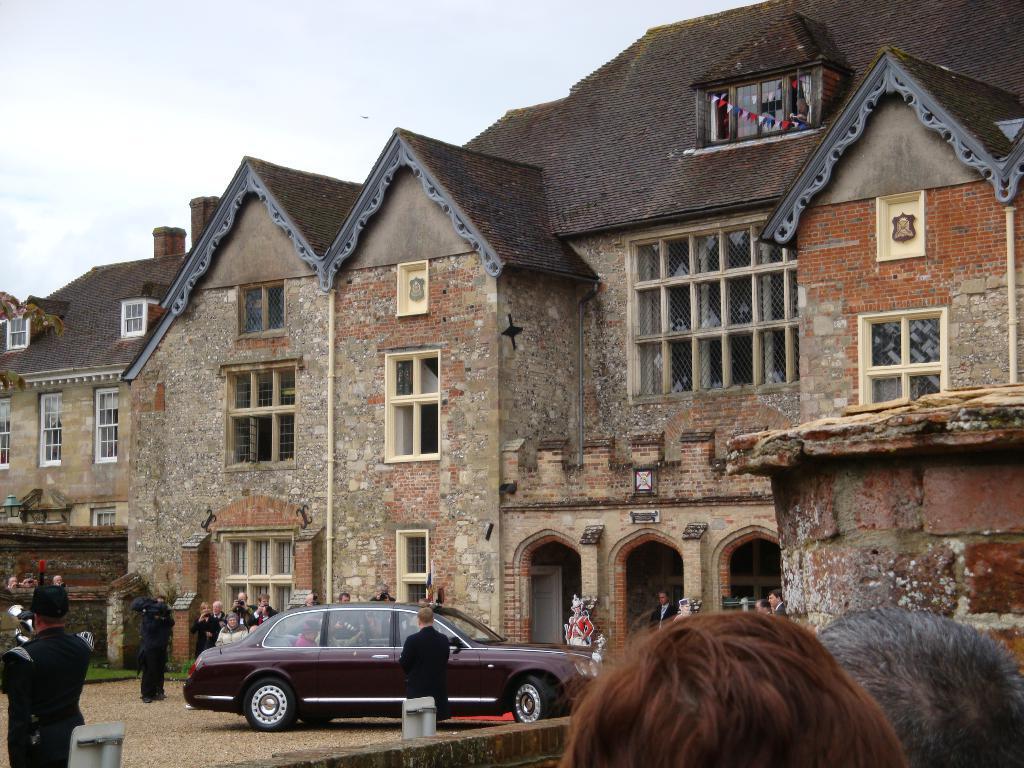Can you describe this image briefly? In this image we can see few buildings with doors and windows and there is a car and we can see some people and at the top we can see the sky. 